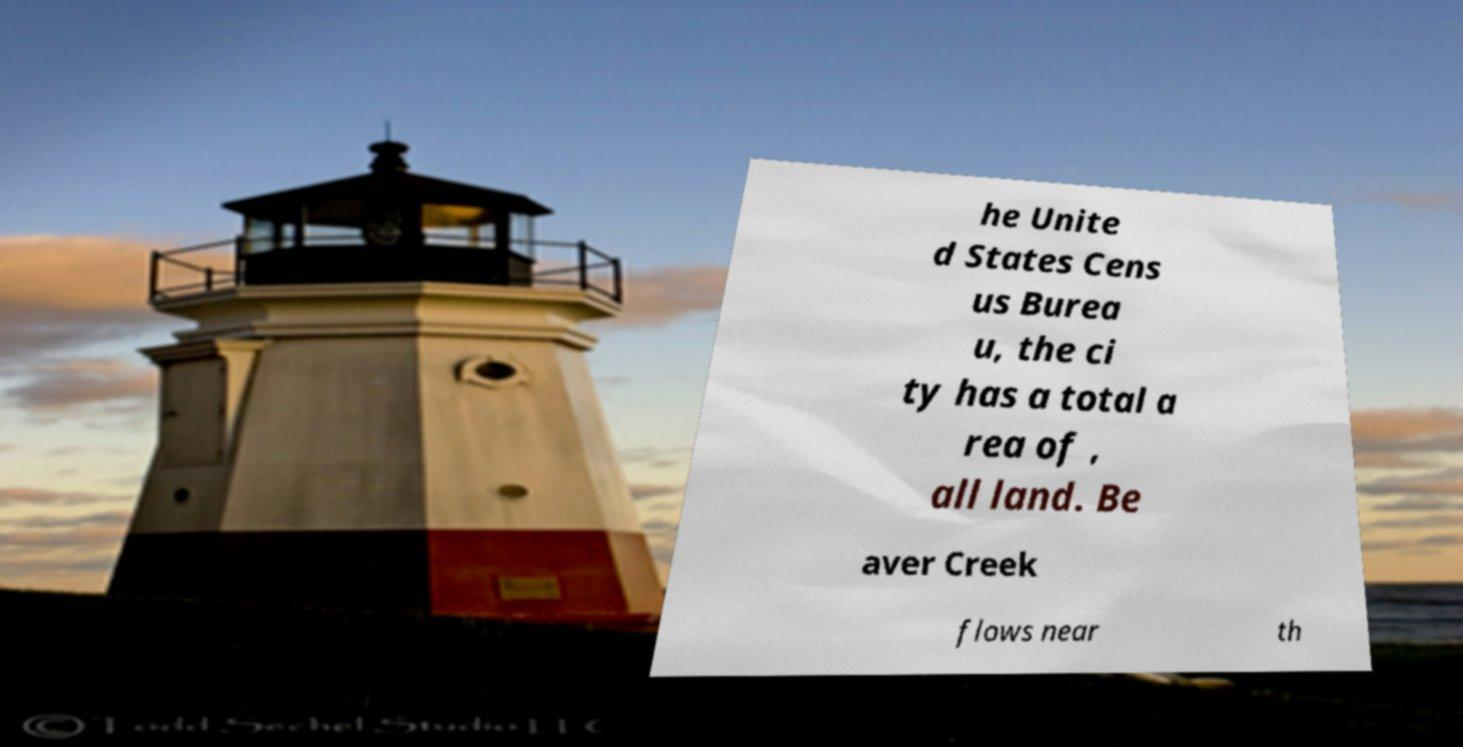Please read and relay the text visible in this image. What does it say? he Unite d States Cens us Burea u, the ci ty has a total a rea of , all land. Be aver Creek flows near th 